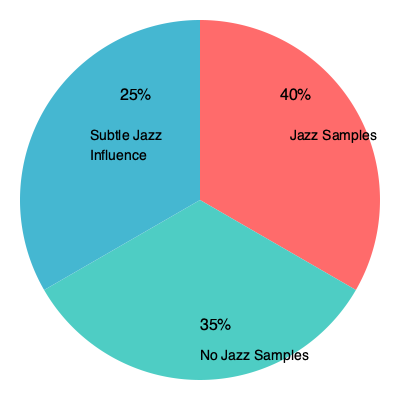Based on the pie chart showing the frequency of jazz elements in East Coast rap, what percentage of tracks feature overt jazz samples? To answer this question, we need to analyze the pie chart provided:

1. The pie chart is divided into three sections, each representing a different category of jazz influence in East Coast rap.

2. The largest section, colored red, is labeled "Jazz Samples" and covers 40% of the chart.

3. The second-largest section, colored teal, is labeled "No Jazz Samples" and covers 35% of the chart.

4. The smallest section, colored blue, is labeled "Subtle Jazz Influence" and covers 25% of the chart.

5. The question asks specifically about "overt jazz samples," which would be represented by the "Jazz Samples" category.

6. Therefore, the percentage of tracks featuring overt jazz samples is 40%.

This data aligns with the persona of an old-school hip-hop fan who appreciates East Coast rap, as it shows a significant influence of jazz in this style of hip-hop, which was indeed a characteristic feature of many East Coast rap productions, especially during the golden age of hip-hop.
Answer: 40% 